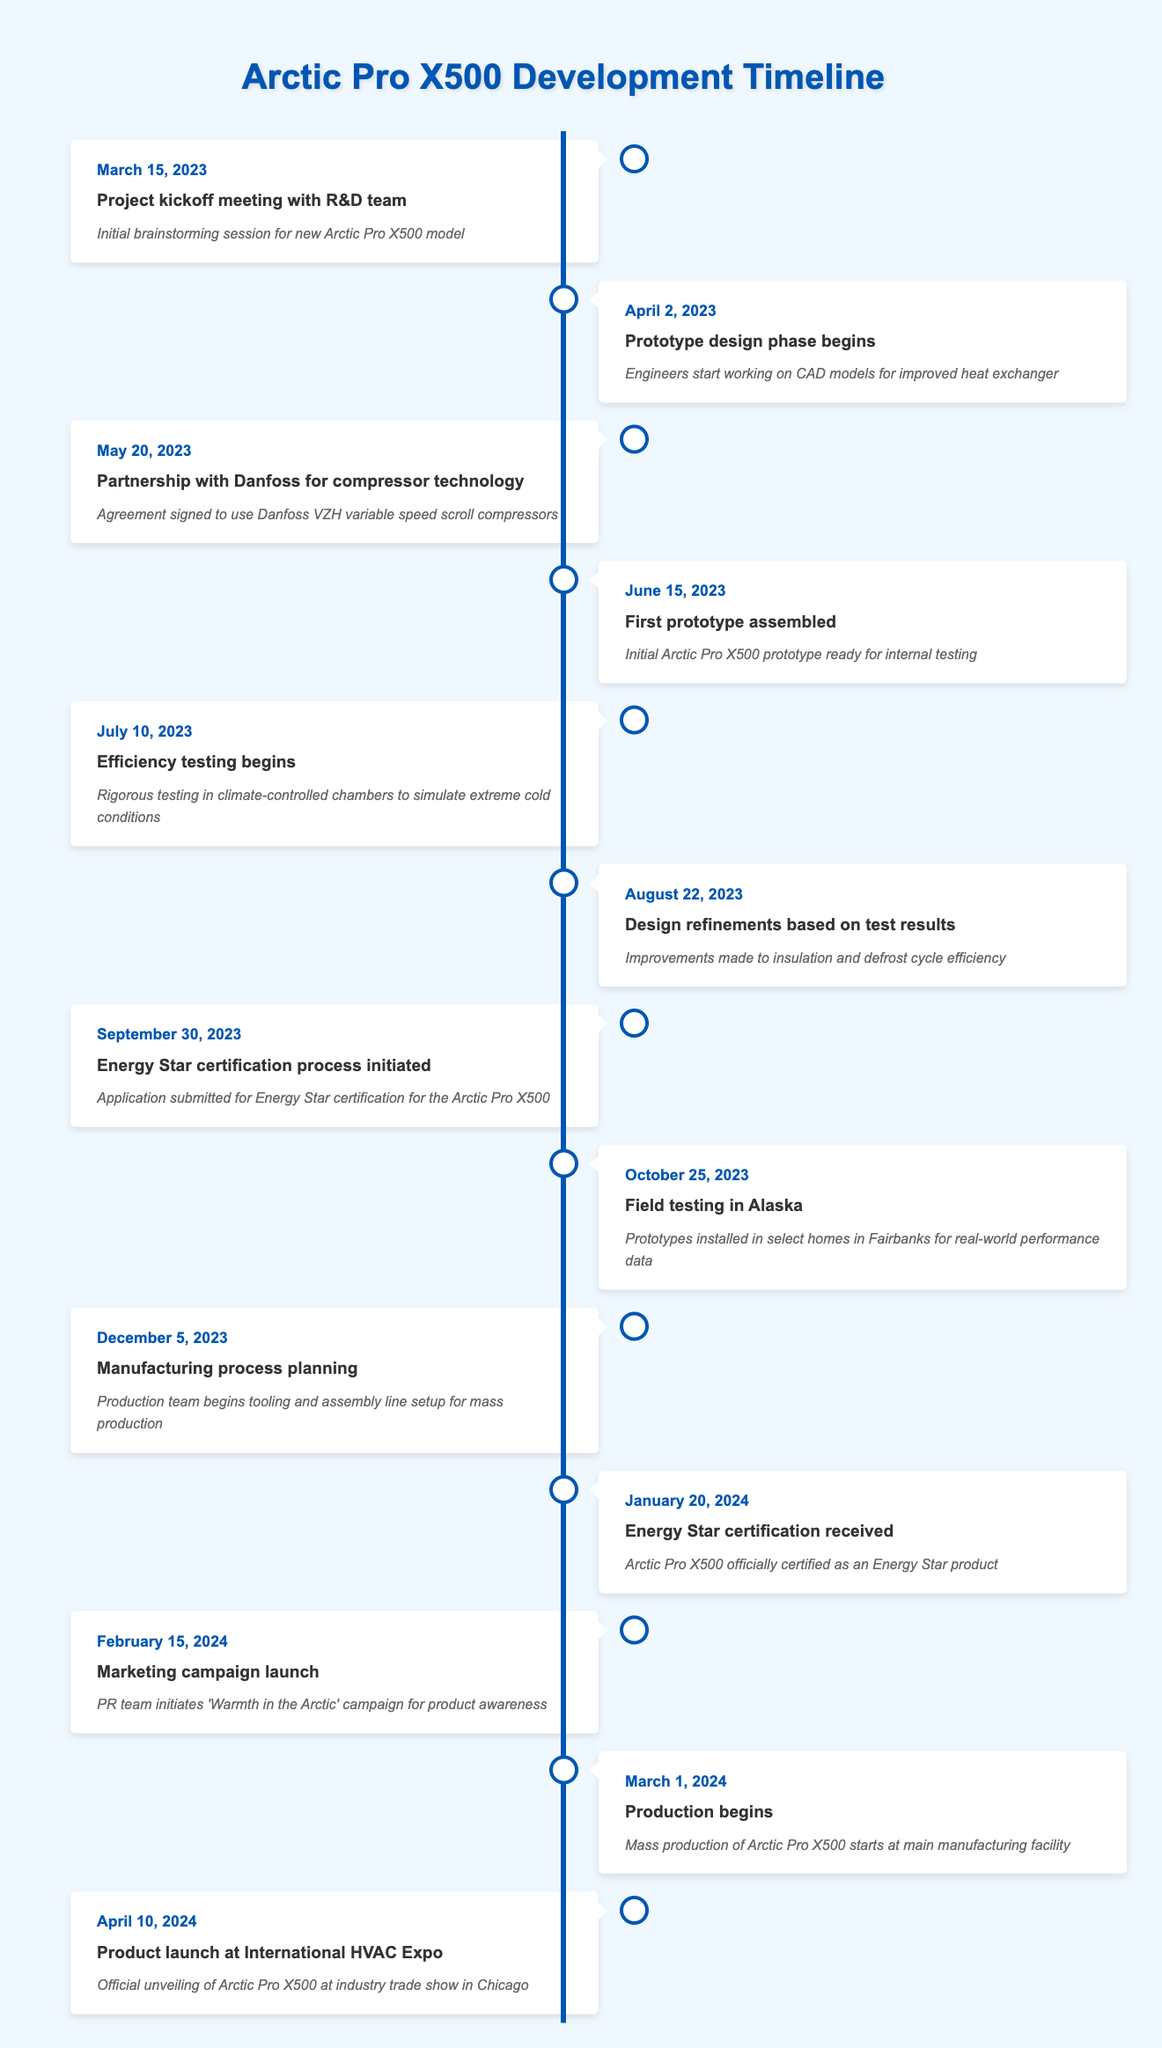What event occurred on June 15, 2023? Referring to the timeline, the entry for June 15, 2023, states that the first prototype of the Arctic Pro X500 was assembled, ready for internal testing.
Answer: First prototype assembled When did the efficiency testing begin? The timeline indicates that efficiency testing began on July 10, 2023.
Answer: July 10, 2023 Is the Arctic Pro X500 expected to launch before Energy Star certification is received? According to the timeline, the Energy Star certification was received on January 20, 2024, while production begins on March 1, 2024. This indicates that the product will launch after receiving the certification.
Answer: No What is the time span from the project kickoff meeting to the first prototype assembly? The project kickoff meeting occurred on March 15, 2023, and the first prototype was assembled on June 15, 2023. The time span between these two dates is exactly three months.
Answer: Three months How many events are scheduled to take place after the Energy Star certification is received? The timeline shows that there are three events listed after the Energy Star certification received on January 20, 2024: marketing campaign launch on February 15, production begins on March 1, and product launch on April 10.
Answer: Three events What improvements were made to the heating system based on efficiency testing? On August 22, 2023, design refinements were made based on testing results, specifically improving insulation and the defrost cycle efficiency.
Answer: Improved insulation and defrost cycle efficiency What was the main focus of the marketing campaign launched on February 15, 2024? The marketing campaign launched on February 15, 2024, was named 'Warmth in the Arctic,' aimed at increasing product awareness for the Arctic Pro X500.
Answer: 'Warmth in the Arctic' campaign Calculate the total duration from the project kickoff meeting to the product launch. The project kickoff meeting was on March 15, 2023, and the product launch is on April 10, 2024. Counting the total days, from March 15, 2023, to April 10, 2024, it sums to 390 days, representing approximately one year and one month.
Answer: 390 days 